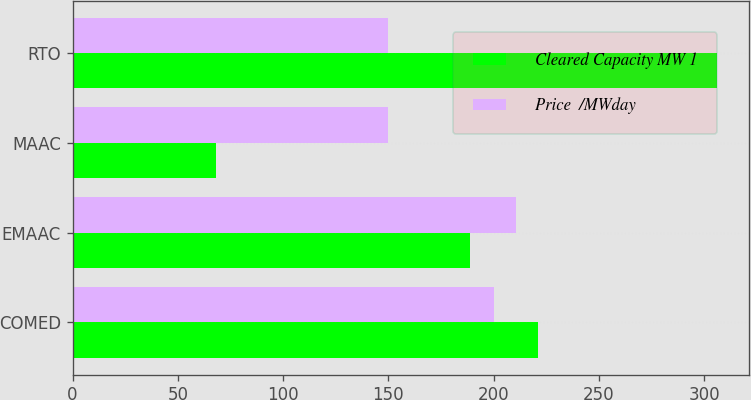<chart> <loc_0><loc_0><loc_500><loc_500><stacked_bar_chart><ecel><fcel>COMED<fcel>EMAAC<fcel>MAAC<fcel>RTO<nl><fcel>Cleared Capacity MW 1<fcel>221<fcel>189<fcel>68<fcel>306<nl><fcel>Price  /MWday<fcel>200.21<fcel>210.63<fcel>149.98<fcel>149.98<nl></chart> 